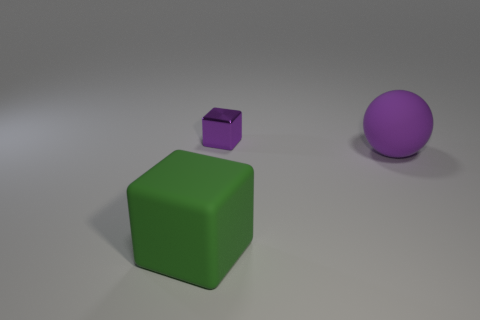Add 2 large green objects. How many objects exist? 5 Subtract all purple cubes. How many cubes are left? 1 Subtract all spheres. How many objects are left? 2 Subtract 1 blocks. How many blocks are left? 1 Subtract all red cylinders. How many green cubes are left? 1 Add 2 large gray matte blocks. How many large gray matte blocks exist? 2 Subtract 0 gray balls. How many objects are left? 3 Subtract all yellow spheres. Subtract all brown blocks. How many spheres are left? 1 Subtract all brown shiny things. Subtract all tiny purple objects. How many objects are left? 2 Add 1 large green things. How many large green things are left? 2 